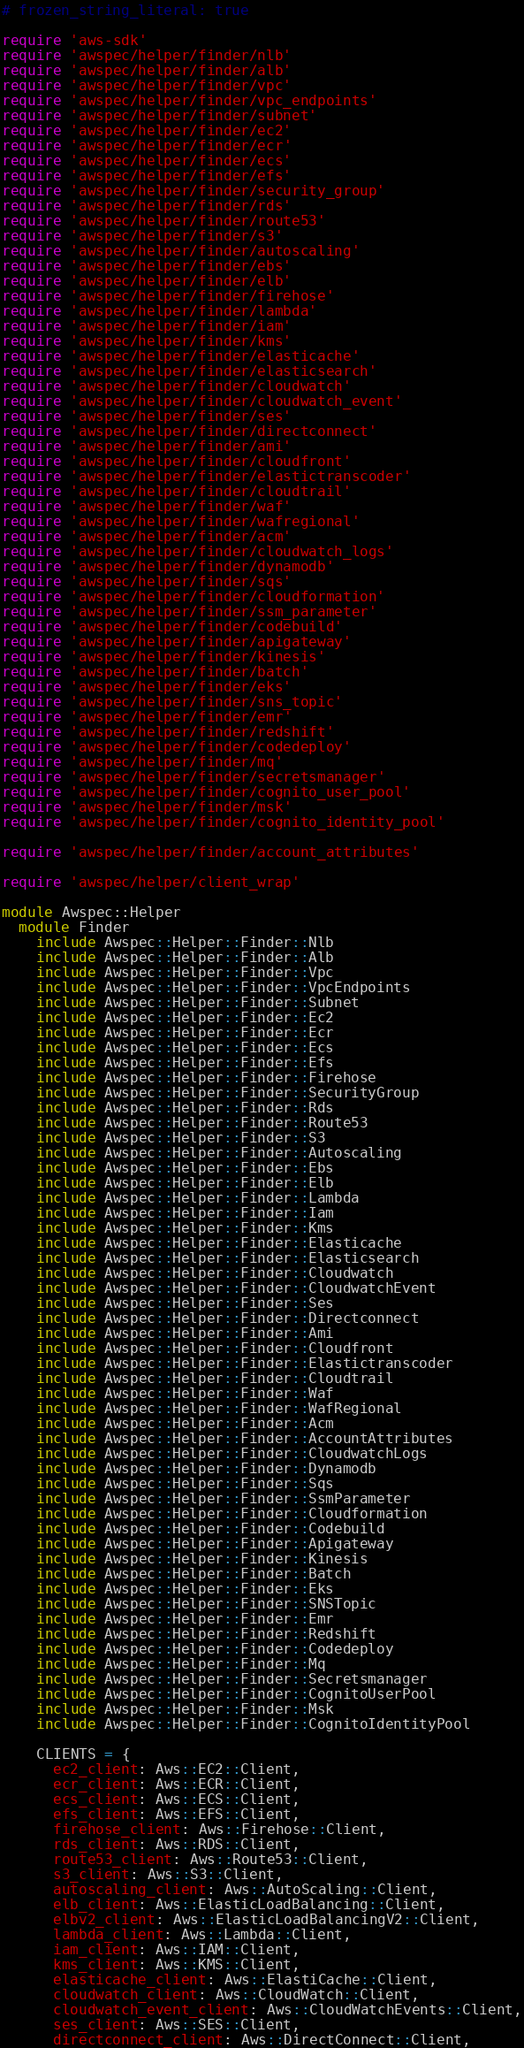<code> <loc_0><loc_0><loc_500><loc_500><_Ruby_># frozen_string_literal: true

require 'aws-sdk'
require 'awspec/helper/finder/nlb'
require 'awspec/helper/finder/alb'
require 'awspec/helper/finder/vpc'
require 'awspec/helper/finder/vpc_endpoints'
require 'awspec/helper/finder/subnet'
require 'awspec/helper/finder/ec2'
require 'awspec/helper/finder/ecr'
require 'awspec/helper/finder/ecs'
require 'awspec/helper/finder/efs'
require 'awspec/helper/finder/security_group'
require 'awspec/helper/finder/rds'
require 'awspec/helper/finder/route53'
require 'awspec/helper/finder/s3'
require 'awspec/helper/finder/autoscaling'
require 'awspec/helper/finder/ebs'
require 'awspec/helper/finder/elb'
require 'awspec/helper/finder/firehose'
require 'awspec/helper/finder/lambda'
require 'awspec/helper/finder/iam'
require 'awspec/helper/finder/kms'
require 'awspec/helper/finder/elasticache'
require 'awspec/helper/finder/elasticsearch'
require 'awspec/helper/finder/cloudwatch'
require 'awspec/helper/finder/cloudwatch_event'
require 'awspec/helper/finder/ses'
require 'awspec/helper/finder/directconnect'
require 'awspec/helper/finder/ami'
require 'awspec/helper/finder/cloudfront'
require 'awspec/helper/finder/elastictranscoder'
require 'awspec/helper/finder/cloudtrail'
require 'awspec/helper/finder/waf'
require 'awspec/helper/finder/wafregional'
require 'awspec/helper/finder/acm'
require 'awspec/helper/finder/cloudwatch_logs'
require 'awspec/helper/finder/dynamodb'
require 'awspec/helper/finder/sqs'
require 'awspec/helper/finder/cloudformation'
require 'awspec/helper/finder/ssm_parameter'
require 'awspec/helper/finder/codebuild'
require 'awspec/helper/finder/apigateway'
require 'awspec/helper/finder/kinesis'
require 'awspec/helper/finder/batch'
require 'awspec/helper/finder/eks'
require 'awspec/helper/finder/sns_topic'
require 'awspec/helper/finder/emr'
require 'awspec/helper/finder/redshift'
require 'awspec/helper/finder/codedeploy'
require 'awspec/helper/finder/mq'
require 'awspec/helper/finder/secretsmanager'
require 'awspec/helper/finder/cognito_user_pool'
require 'awspec/helper/finder/msk'
require 'awspec/helper/finder/cognito_identity_pool'

require 'awspec/helper/finder/account_attributes'

require 'awspec/helper/client_wrap'

module Awspec::Helper
  module Finder
    include Awspec::Helper::Finder::Nlb
    include Awspec::Helper::Finder::Alb
    include Awspec::Helper::Finder::Vpc
    include Awspec::Helper::Finder::VpcEndpoints
    include Awspec::Helper::Finder::Subnet
    include Awspec::Helper::Finder::Ec2
    include Awspec::Helper::Finder::Ecr
    include Awspec::Helper::Finder::Ecs
    include Awspec::Helper::Finder::Efs
    include Awspec::Helper::Finder::Firehose
    include Awspec::Helper::Finder::SecurityGroup
    include Awspec::Helper::Finder::Rds
    include Awspec::Helper::Finder::Route53
    include Awspec::Helper::Finder::S3
    include Awspec::Helper::Finder::Autoscaling
    include Awspec::Helper::Finder::Ebs
    include Awspec::Helper::Finder::Elb
    include Awspec::Helper::Finder::Lambda
    include Awspec::Helper::Finder::Iam
    include Awspec::Helper::Finder::Kms
    include Awspec::Helper::Finder::Elasticache
    include Awspec::Helper::Finder::Elasticsearch
    include Awspec::Helper::Finder::Cloudwatch
    include Awspec::Helper::Finder::CloudwatchEvent
    include Awspec::Helper::Finder::Ses
    include Awspec::Helper::Finder::Directconnect
    include Awspec::Helper::Finder::Ami
    include Awspec::Helper::Finder::Cloudfront
    include Awspec::Helper::Finder::Elastictranscoder
    include Awspec::Helper::Finder::Cloudtrail
    include Awspec::Helper::Finder::Waf
    include Awspec::Helper::Finder::WafRegional
    include Awspec::Helper::Finder::Acm
    include Awspec::Helper::Finder::AccountAttributes
    include Awspec::Helper::Finder::CloudwatchLogs
    include Awspec::Helper::Finder::Dynamodb
    include Awspec::Helper::Finder::Sqs
    include Awspec::Helper::Finder::SsmParameter
    include Awspec::Helper::Finder::Cloudformation
    include Awspec::Helper::Finder::Codebuild
    include Awspec::Helper::Finder::Apigateway
    include Awspec::Helper::Finder::Kinesis
    include Awspec::Helper::Finder::Batch
    include Awspec::Helper::Finder::Eks
    include Awspec::Helper::Finder::SNSTopic
    include Awspec::Helper::Finder::Emr
    include Awspec::Helper::Finder::Redshift
    include Awspec::Helper::Finder::Codedeploy
    include Awspec::Helper::Finder::Mq
    include Awspec::Helper::Finder::Secretsmanager
    include Awspec::Helper::Finder::CognitoUserPool
    include Awspec::Helper::Finder::Msk
    include Awspec::Helper::Finder::CognitoIdentityPool

    CLIENTS = {
      ec2_client: Aws::EC2::Client,
      ecr_client: Aws::ECR::Client,
      ecs_client: Aws::ECS::Client,
      efs_client: Aws::EFS::Client,
      firehose_client: Aws::Firehose::Client,
      rds_client: Aws::RDS::Client,
      route53_client: Aws::Route53::Client,
      s3_client: Aws::S3::Client,
      autoscaling_client: Aws::AutoScaling::Client,
      elb_client: Aws::ElasticLoadBalancing::Client,
      elbv2_client: Aws::ElasticLoadBalancingV2::Client,
      lambda_client: Aws::Lambda::Client,
      iam_client: Aws::IAM::Client,
      kms_client: Aws::KMS::Client,
      elasticache_client: Aws::ElastiCache::Client,
      cloudwatch_client: Aws::CloudWatch::Client,
      cloudwatch_event_client: Aws::CloudWatchEvents::Client,
      ses_client: Aws::SES::Client,
      directconnect_client: Aws::DirectConnect::Client,</code> 